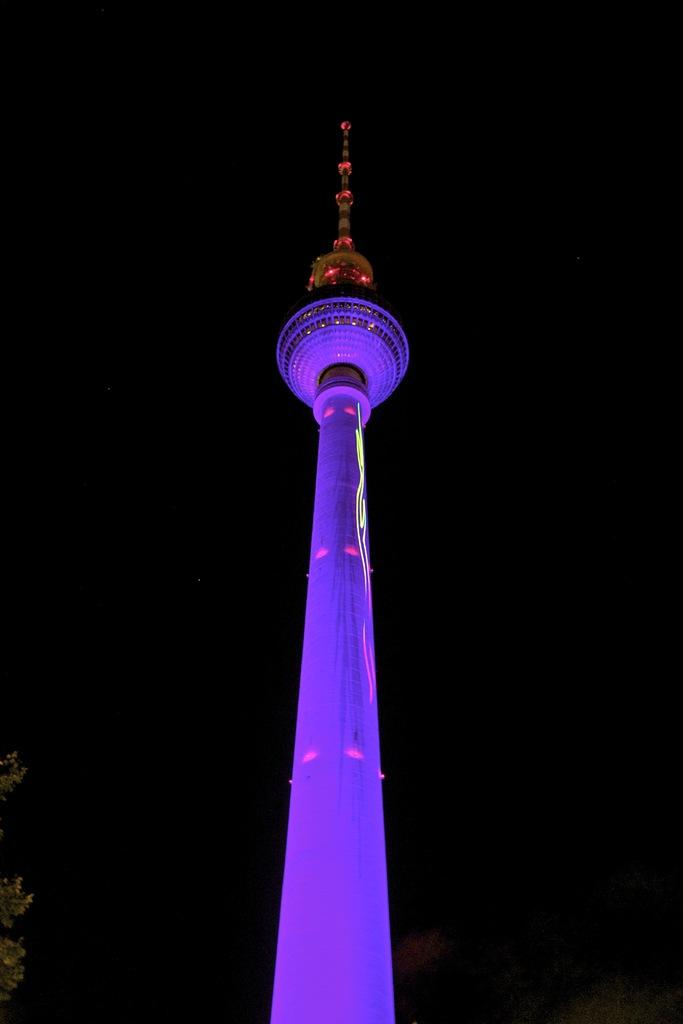What is the main structure in the image? There is a tower in the image. How would you describe the overall appearance of the image? The background of the image is dark. What type of vegetation can be seen in the image? There is a tree at the left bottom of the image. What type of quilt is draped over the tower in the image? There is no quilt present in the image; it only the tower, a dark background, and a tree are visible. Can you tell me how many scissors are lying on the ground near the tree in the image? There are no scissors present in the image; only the tower, a dark background, and a tree are visible. 